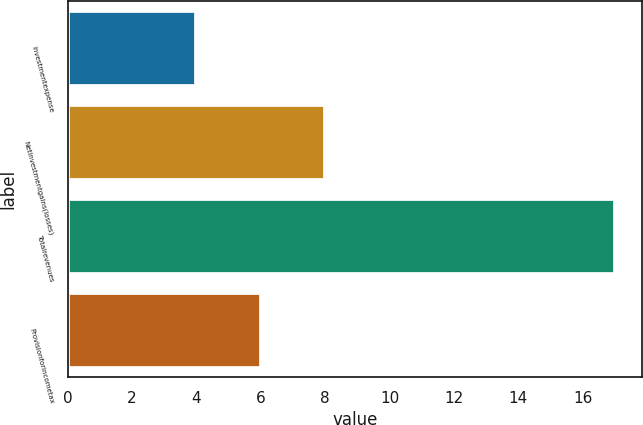Convert chart. <chart><loc_0><loc_0><loc_500><loc_500><bar_chart><fcel>Investmentexpense<fcel>Netinvestmentgains(losses)<fcel>Totalrevenues<fcel>Provisionforincometax<nl><fcel>4<fcel>8<fcel>17<fcel>6<nl></chart> 